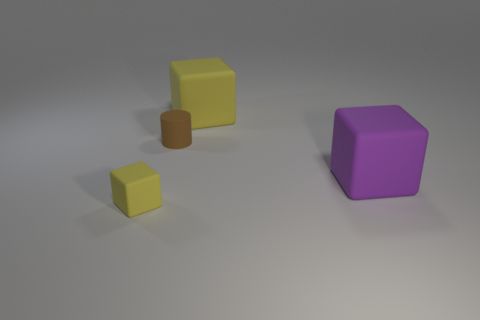What shape is the large rubber thing that is the same color as the tiny rubber block?
Offer a very short reply. Cube. Is there a tiny green thing made of the same material as the brown cylinder?
Offer a very short reply. No. There is a yellow object behind the small matte cylinder; is its shape the same as the small brown thing?
Give a very brief answer. No. What number of small brown objects are in front of the yellow thing that is right of the yellow rubber cube that is in front of the small brown cylinder?
Ensure brevity in your answer.  1. Is the number of large rubber cubes behind the tiny cylinder less than the number of rubber objects on the right side of the small yellow thing?
Offer a very short reply. Yes. The small rubber thing that is the same shape as the large yellow thing is what color?
Your answer should be compact. Yellow. How big is the cylinder?
Your answer should be compact. Small. How many purple matte blocks are the same size as the purple rubber object?
Make the answer very short. 0. Is the number of big yellow objects greater than the number of tiny yellow metal cubes?
Your answer should be compact. Yes. Is there anything else of the same color as the cylinder?
Give a very brief answer. No. 